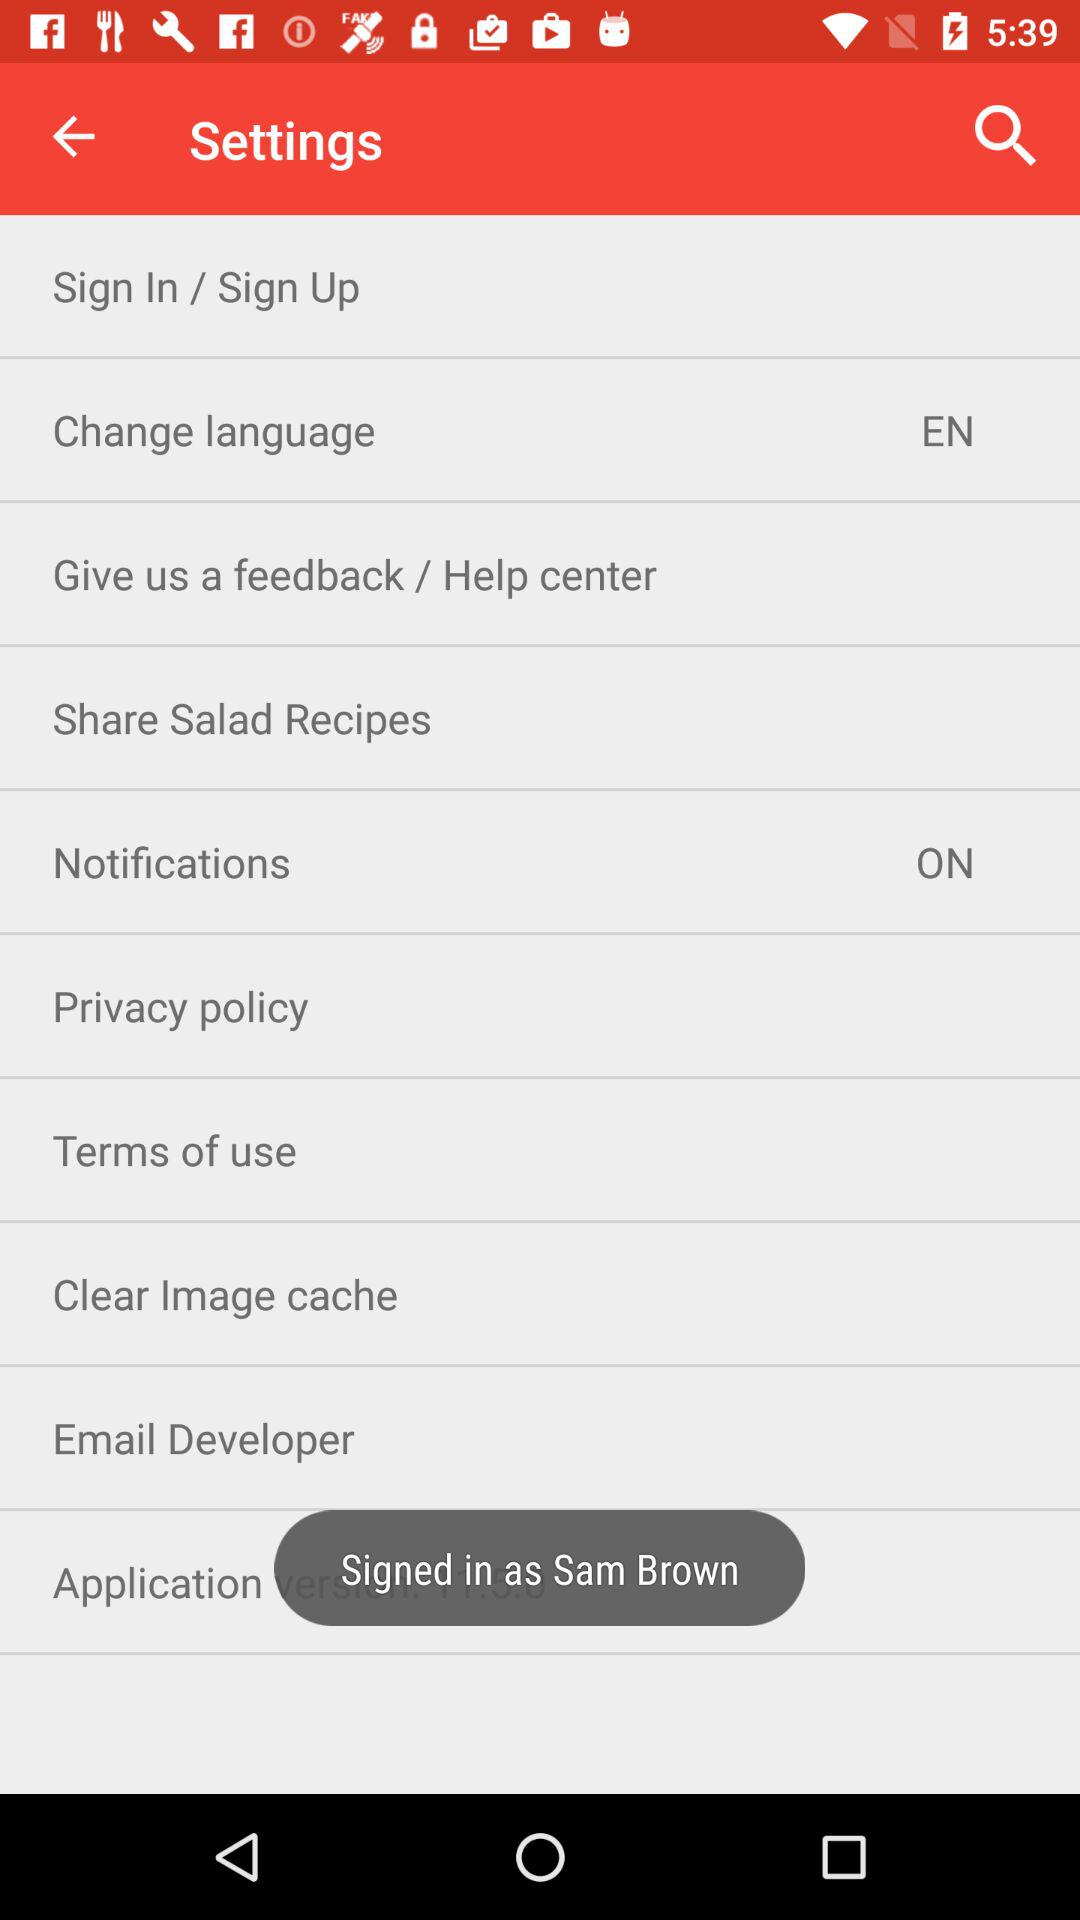What is the status of the "Notifications" settings? The status of the "Notifications" settings is "on". 